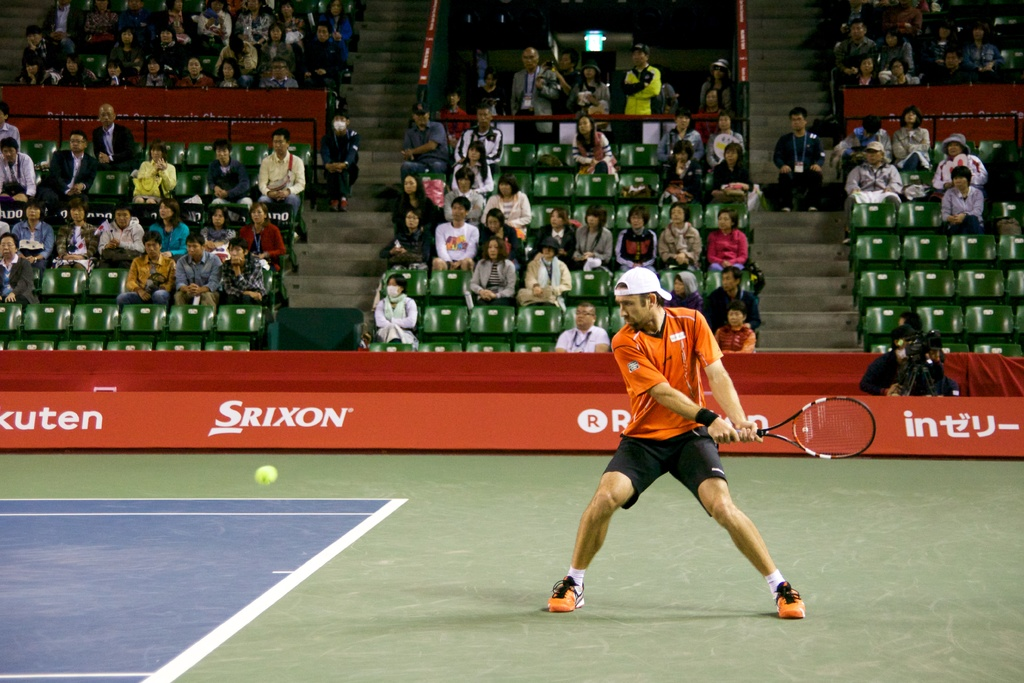Provide a one-sentence caption for the provided image. A focused tennis player prepares to fiercely return a serve at an indoor court, under the observant eyes of the audience and against a backdrop prominently displaying a Srixon advertisement. 